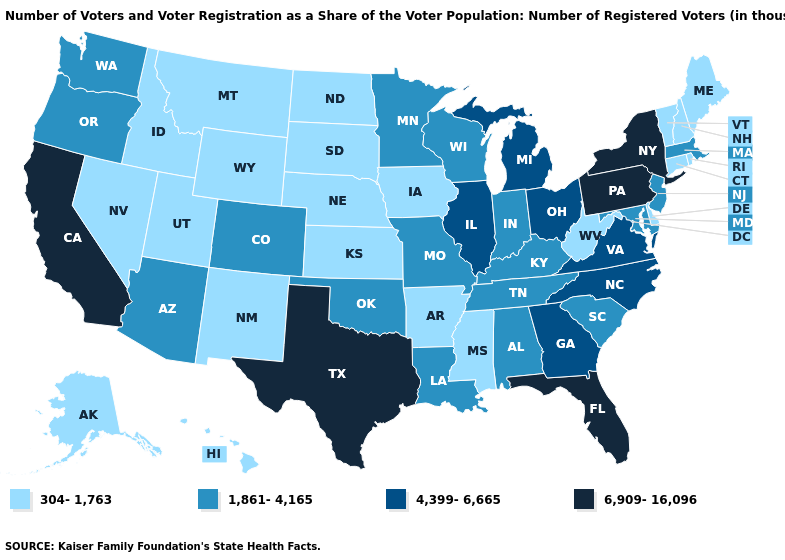What is the highest value in the Northeast ?
Keep it brief. 6,909-16,096. What is the highest value in states that border New York?
Give a very brief answer. 6,909-16,096. Does Vermont have the highest value in the USA?
Answer briefly. No. What is the value of Nevada?
Answer briefly. 304-1,763. What is the highest value in the USA?
Quick response, please. 6,909-16,096. Name the states that have a value in the range 4,399-6,665?
Quick response, please. Georgia, Illinois, Michigan, North Carolina, Ohio, Virginia. What is the highest value in the USA?
Be succinct. 6,909-16,096. Name the states that have a value in the range 6,909-16,096?
Answer briefly. California, Florida, New York, Pennsylvania, Texas. Does the first symbol in the legend represent the smallest category?
Answer briefly. Yes. Among the states that border Arkansas , does Texas have the highest value?
Short answer required. Yes. What is the value of Nevada?
Write a very short answer. 304-1,763. How many symbols are there in the legend?
Quick response, please. 4. Which states have the lowest value in the Northeast?
Write a very short answer. Connecticut, Maine, New Hampshire, Rhode Island, Vermont. Which states hav the highest value in the West?
Quick response, please. California. What is the value of North Dakota?
Be succinct. 304-1,763. 